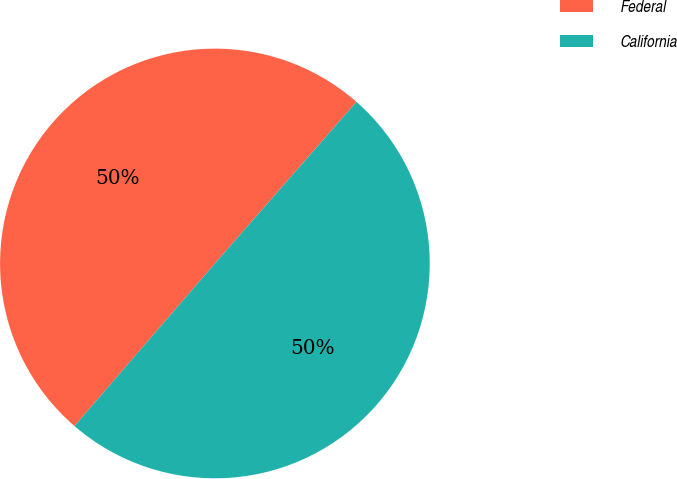Convert chart to OTSL. <chart><loc_0><loc_0><loc_500><loc_500><pie_chart><fcel>Federal<fcel>California<nl><fcel>50.11%<fcel>49.89%<nl></chart> 